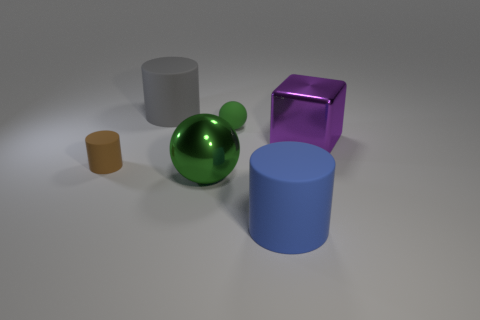What is the size of the metallic thing on the right side of the green metallic sphere?
Your response must be concise. Large. Does the small brown object have the same material as the gray cylinder?
Make the answer very short. Yes. Are there any big shiny objects right of the large cylinder that is on the right side of the cylinder behind the large purple metal cube?
Your answer should be very brief. Yes. The large block is what color?
Your answer should be very brief. Purple. The shiny thing that is the same size as the green metal ball is what color?
Offer a very short reply. Purple. Is the shape of the big object that is to the left of the big green sphere the same as  the big purple thing?
Your answer should be very brief. No. There is a metallic object that is left of the large rubber cylinder on the right side of the rubber cylinder that is behind the purple shiny block; what color is it?
Provide a succinct answer. Green. Is there a tiny rubber cube?
Provide a short and direct response. No. What number of other objects are there of the same size as the blue rubber cylinder?
Give a very brief answer. 3. Do the rubber sphere and the sphere that is in front of the brown object have the same color?
Provide a short and direct response. Yes. 